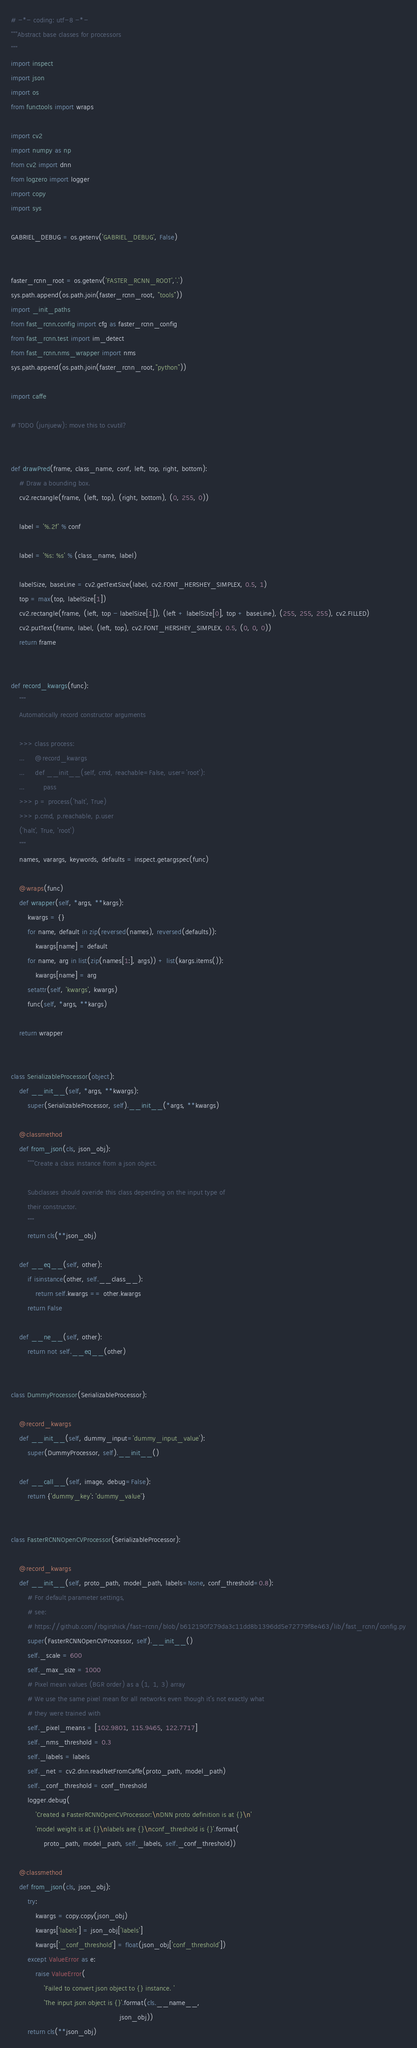<code> <loc_0><loc_0><loc_500><loc_500><_Python_>
# -*- coding: utf-8 -*-
"""Abstract base classes for processors
"""
import inspect
import json
import os
from functools import wraps

import cv2
import numpy as np
from cv2 import dnn
from logzero import logger
import copy
import sys

GABRIEL_DEBUG = os.getenv('GABRIEL_DEBUG', False)


faster_rcnn_root = os.getenv('FASTER_RCNN_ROOT','.')
sys.path.append(os.path.join(faster_rcnn_root, "tools"))
import _init_paths
from fast_rcnn.config import cfg as faster_rcnn_config
from fast_rcnn.test import im_detect
from fast_rcnn.nms_wrapper import nms
sys.path.append(os.path.join(faster_rcnn_root,"python"))

import caffe

# TODO (junjuew): move this to cvutil?


def drawPred(frame, class_name, conf, left, top, right, bottom):
    # Draw a bounding box.
    cv2.rectangle(frame, (left, top), (right, bottom), (0, 255, 0))

    label = '%.2f' % conf

    label = '%s: %s' % (class_name, label)

    labelSize, baseLine = cv2.getTextSize(label, cv2.FONT_HERSHEY_SIMPLEX, 0.5, 1)
    top = max(top, labelSize[1])
    cv2.rectangle(frame, (left, top - labelSize[1]), (left + labelSize[0], top + baseLine), (255, 255, 255), cv2.FILLED)
    cv2.putText(frame, label, (left, top), cv2.FONT_HERSHEY_SIMPLEX, 0.5, (0, 0, 0))
    return frame


def record_kwargs(func):
    """
    Automatically record constructor arguments

    >>> class process:
    ...     @record_kwargs
    ...     def __init__(self, cmd, reachable=False, user='root'):
    ...         pass
    >>> p = process('halt', True)
    >>> p.cmd, p.reachable, p.user
    ('halt', True, 'root')
    """
    names, varargs, keywords, defaults = inspect.getargspec(func)

    @wraps(func)
    def wrapper(self, *args, **kargs):
        kwargs = {}
        for name, default in zip(reversed(names), reversed(defaults)):
            kwargs[name] = default
        for name, arg in list(zip(names[1:], args)) + list(kargs.items()):
            kwargs[name] = arg
        setattr(self, 'kwargs', kwargs)
        func(self, *args, **kargs)

    return wrapper


class SerializableProcessor(object):
    def __init__(self, *args, **kwargs):
        super(SerializableProcessor, self).__init__(*args, **kwargs)

    @classmethod
    def from_json(cls, json_obj):
        """Create a class instance from a json object.

        Subclasses should overide this class depending on the input type of
        their constructor.
        """
        return cls(**json_obj)

    def __eq__(self, other):
        if isinstance(other, self.__class__):
            return self.kwargs == other.kwargs
        return False

    def __ne__(self, other):
        return not self.__eq__(other)


class DummyProcessor(SerializableProcessor):

    @record_kwargs
    def __init__(self, dummy_input='dummy_input_value'):
        super(DummyProcessor, self).__init__()

    def __call__(self, image, debug=False):
        return {'dummy_key': 'dummy_value'}


class FasterRCNNOpenCVProcessor(SerializableProcessor):

    @record_kwargs
    def __init__(self, proto_path, model_path, labels=None, conf_threshold=0.8):
        # For default parameter settings,
        # see:
        # https://github.com/rbgirshick/fast-rcnn/blob/b612190f279da3c11dd8b1396dd5e72779f8e463/lib/fast_rcnn/config.py
        super(FasterRCNNOpenCVProcessor, self).__init__()
        self._scale = 600
        self._max_size = 1000
        # Pixel mean values (BGR order) as a (1, 1, 3) array
        # We use the same pixel mean for all networks even though it's not exactly what
        # they were trained with
        self._pixel_means = [102.9801, 115.9465, 122.7717]
        self._nms_threshold = 0.3
        self._labels = labels
        self._net = cv2.dnn.readNetFromCaffe(proto_path, model_path)
        self._conf_threshold = conf_threshold
        logger.debug(
            'Created a FasterRCNNOpenCVProcessor:\nDNN proto definition is at {}\n'
            'model weight is at {}\nlabels are {}\nconf_threshold is {}'.format(
                proto_path, model_path, self._labels, self._conf_threshold))

    @classmethod
    def from_json(cls, json_obj):
        try:
            kwargs = copy.copy(json_obj)
            kwargs['labels'] = json_obj['labels']
            kwargs['_conf_threshold'] = float(json_obj['conf_threshold'])
        except ValueError as e:
            raise ValueError(
                'Failed to convert json object to {} instance. '
                'The input json object is {}'.format(cls.__name__,
                                                     json_obj))
        return cls(**json_obj)
</code> 